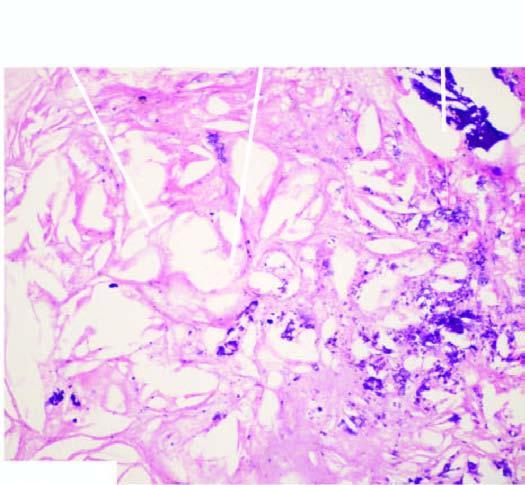s there narrowing of the lumen of coronary due to fully developed atheromatous plaque which has dystrophic calcification in its core?
Answer the question using a single word or phrase. Yes 